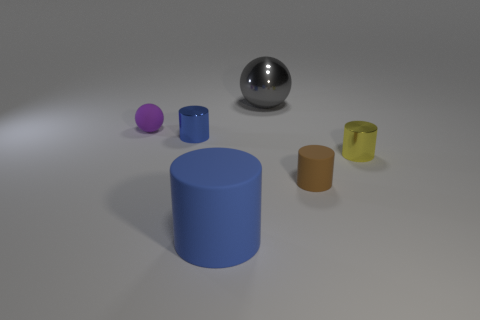Can you describe the lighting and mood of this scene? The scene is softly lit with diffused light that casts gentle shadows, giving the collection of objects a calm and composed ambiance. The lighting doesn't appear to be very directional, which contributes to the serene mood. 